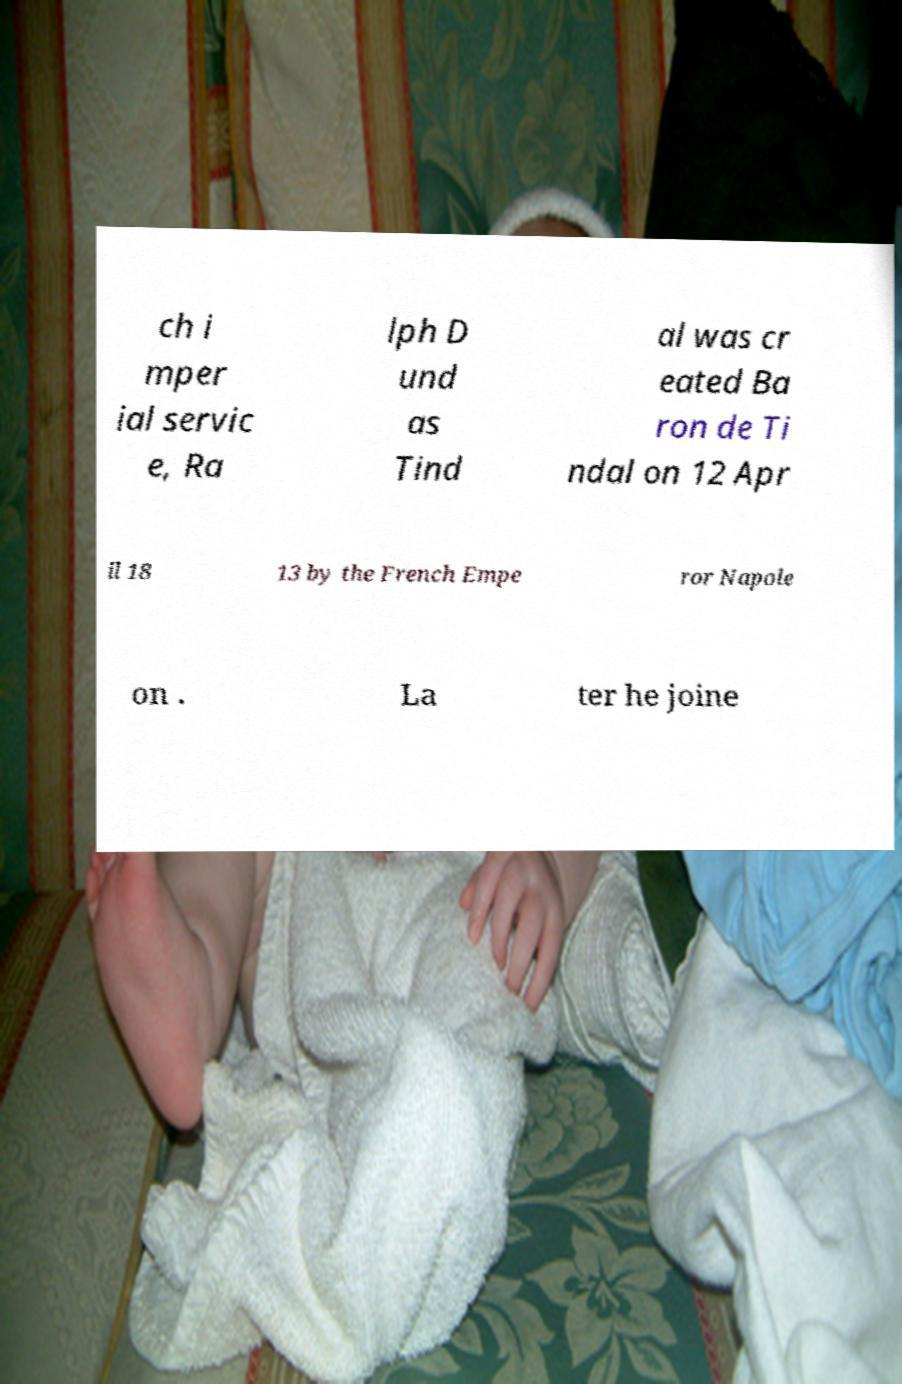For documentation purposes, I need the text within this image transcribed. Could you provide that? ch i mper ial servic e, Ra lph D und as Tind al was cr eated Ba ron de Ti ndal on 12 Apr il 18 13 by the French Empe ror Napole on . La ter he joine 